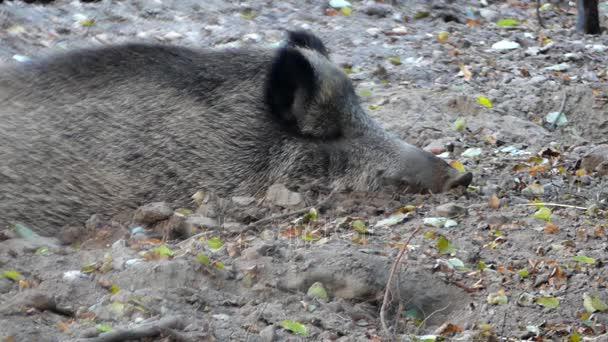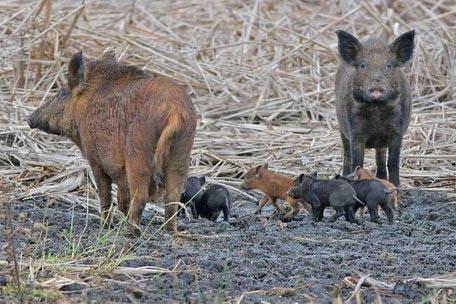The first image is the image on the left, the second image is the image on the right. For the images shown, is this caption "The left image contains no more than three wild boars." true? Answer yes or no. Yes. 